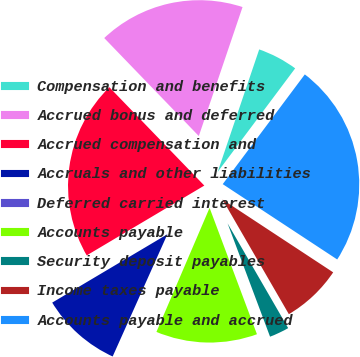Convert chart to OTSL. <chart><loc_0><loc_0><loc_500><loc_500><pie_chart><fcel>Compensation and benefits<fcel>Accrued bonus and deferred<fcel>Accrued compensation and<fcel>Accruals and other liabilities<fcel>Deferred carried interest<fcel>Accounts payable<fcel>Security deposit payables<fcel>Income taxes payable<fcel>Accounts payable and accrued<nl><fcel>5.02%<fcel>17.42%<fcel>21.31%<fcel>9.77%<fcel>0.26%<fcel>12.15%<fcel>2.64%<fcel>7.39%<fcel>24.04%<nl></chart> 